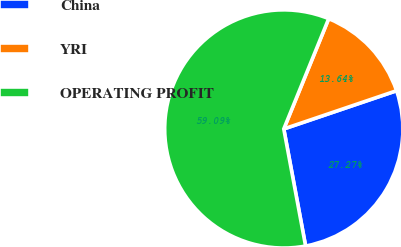Convert chart. <chart><loc_0><loc_0><loc_500><loc_500><pie_chart><fcel>China<fcel>YRI<fcel>OPERATING PROFIT<nl><fcel>27.27%<fcel>13.64%<fcel>59.09%<nl></chart> 